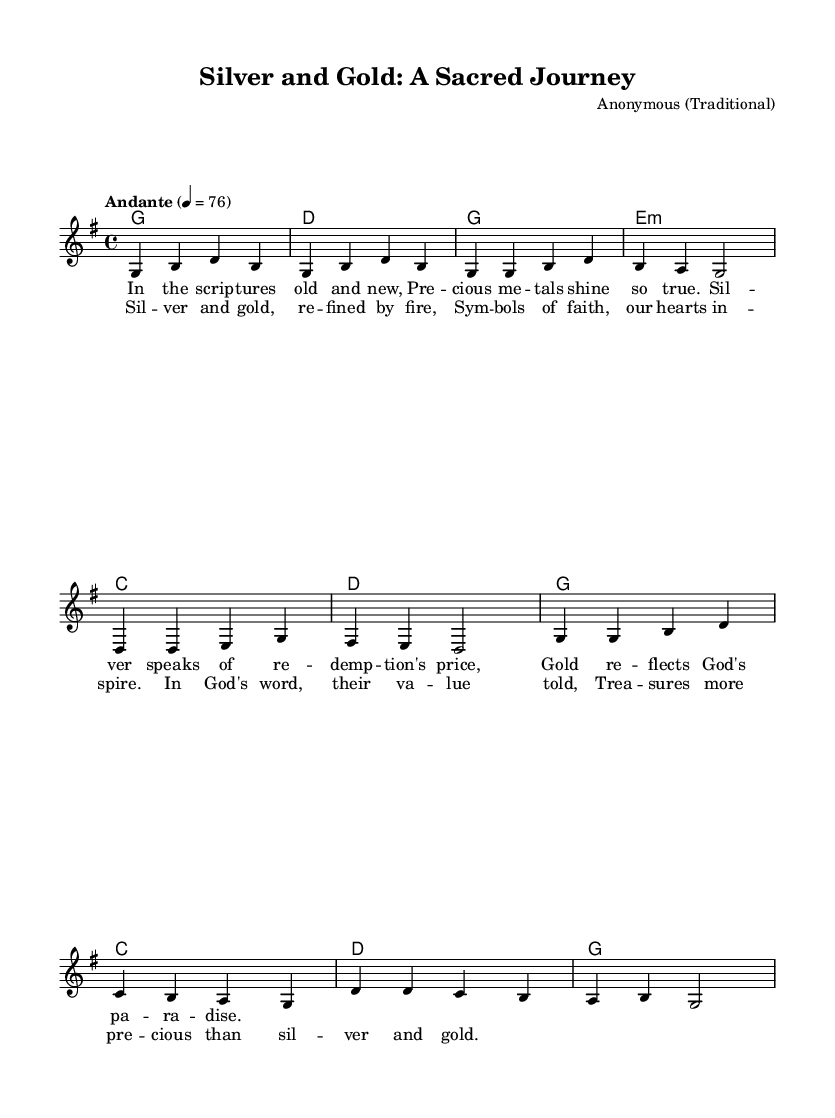What is the key signature of this music? The key signature is G major, indicated by an F sharp in the music.
Answer: G major What is the time signature of the piece? The time signature shown is 4/4, which means there are four beats in each measure.
Answer: 4/4 What is the tempo marking for this piece? The tempo marking states "Andante" and indicates a speed of 76 beats per minute.
Answer: Andante, 76 How many measures are in the chorus section? The chorus has four measures, based on the provided notation structure.
Answer: Four What theme is expressed in the lyrics of this piece? The lyrics primarily explore the symbolism of precious metals and their connection to faith and redemption.
Answer: Symbolism of precious metals What does the repeated use of "refined by fire" symbolize in the context of traditional religious music? "Refined by fire" symbolizes purity and spiritual refinement, reflecting the process of being tested and made holy.
Answer: Purity and spiritual refinement What do silver and gold symbolize in the lyrics? Silver symbolizes redemption's price, while gold reflects God's paradise, indicating their spiritual significance.
Answer: Redemption and paradise 